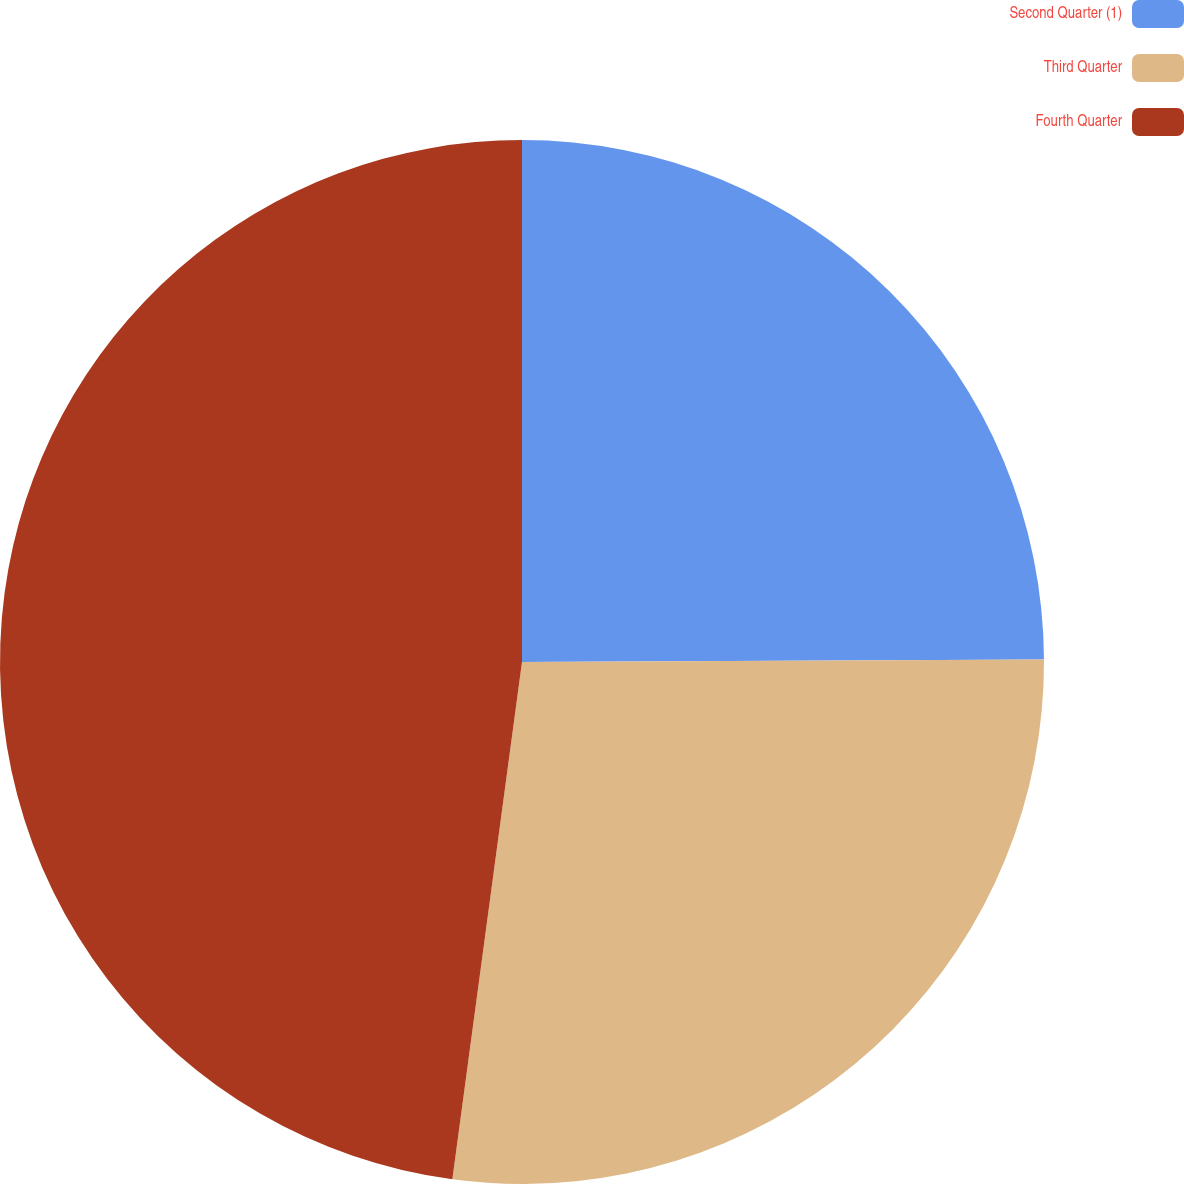<chart> <loc_0><loc_0><loc_500><loc_500><pie_chart><fcel>Second Quarter (1)<fcel>Third Quarter<fcel>Fourth Quarter<nl><fcel>24.92%<fcel>27.21%<fcel>47.87%<nl></chart> 